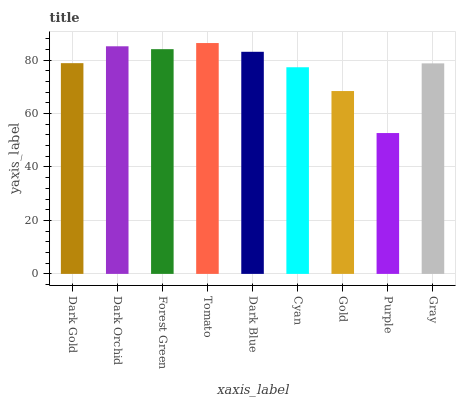Is Purple the minimum?
Answer yes or no. Yes. Is Tomato the maximum?
Answer yes or no. Yes. Is Dark Orchid the minimum?
Answer yes or no. No. Is Dark Orchid the maximum?
Answer yes or no. No. Is Dark Orchid greater than Dark Gold?
Answer yes or no. Yes. Is Dark Gold less than Dark Orchid?
Answer yes or no. Yes. Is Dark Gold greater than Dark Orchid?
Answer yes or no. No. Is Dark Orchid less than Dark Gold?
Answer yes or no. No. Is Dark Gold the high median?
Answer yes or no. Yes. Is Dark Gold the low median?
Answer yes or no. Yes. Is Dark Blue the high median?
Answer yes or no. No. Is Gold the low median?
Answer yes or no. No. 